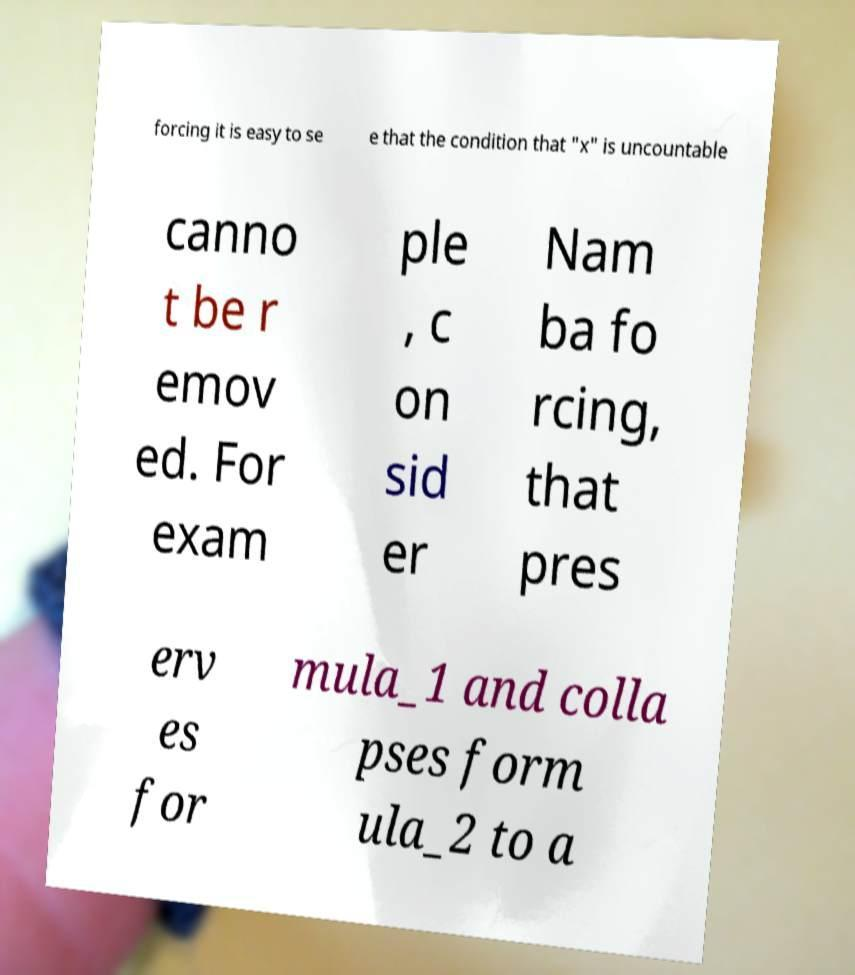Please identify and transcribe the text found in this image. forcing it is easy to se e that the condition that "x" is uncountable canno t be r emov ed. For exam ple , c on sid er Nam ba fo rcing, that pres erv es for mula_1 and colla pses form ula_2 to a 